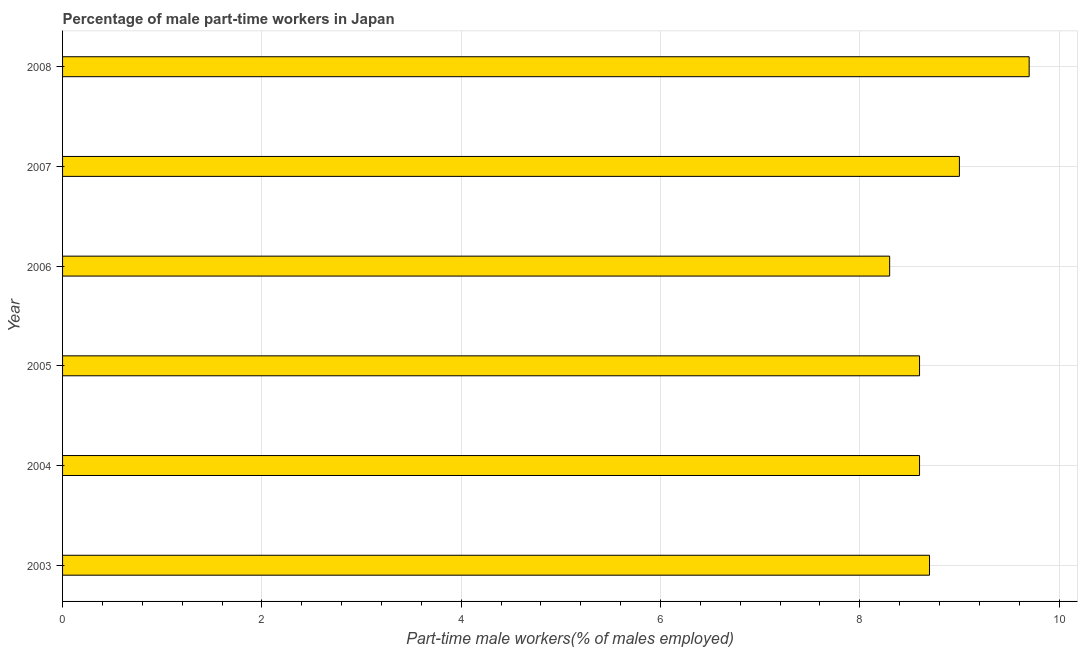Does the graph contain any zero values?
Keep it short and to the point. No. Does the graph contain grids?
Give a very brief answer. Yes. What is the title of the graph?
Ensure brevity in your answer.  Percentage of male part-time workers in Japan. What is the label or title of the X-axis?
Keep it short and to the point. Part-time male workers(% of males employed). What is the label or title of the Y-axis?
Ensure brevity in your answer.  Year. What is the percentage of part-time male workers in 2005?
Provide a short and direct response. 8.6. Across all years, what is the maximum percentage of part-time male workers?
Give a very brief answer. 9.7. Across all years, what is the minimum percentage of part-time male workers?
Your answer should be very brief. 8.3. In which year was the percentage of part-time male workers minimum?
Offer a very short reply. 2006. What is the sum of the percentage of part-time male workers?
Offer a very short reply. 52.9. What is the average percentage of part-time male workers per year?
Your response must be concise. 8.82. What is the median percentage of part-time male workers?
Your answer should be very brief. 8.65. What is the ratio of the percentage of part-time male workers in 2004 to that in 2007?
Make the answer very short. 0.96. Is the difference between the percentage of part-time male workers in 2003 and 2007 greater than the difference between any two years?
Your answer should be very brief. No. What is the difference between the highest and the second highest percentage of part-time male workers?
Give a very brief answer. 0.7. Are the values on the major ticks of X-axis written in scientific E-notation?
Your response must be concise. No. What is the Part-time male workers(% of males employed) of 2003?
Keep it short and to the point. 8.7. What is the Part-time male workers(% of males employed) in 2004?
Your response must be concise. 8.6. What is the Part-time male workers(% of males employed) in 2005?
Provide a short and direct response. 8.6. What is the Part-time male workers(% of males employed) in 2006?
Offer a very short reply. 8.3. What is the Part-time male workers(% of males employed) of 2008?
Your answer should be compact. 9.7. What is the difference between the Part-time male workers(% of males employed) in 2003 and 2005?
Offer a very short reply. 0.1. What is the difference between the Part-time male workers(% of males employed) in 2004 and 2005?
Offer a terse response. 0. What is the difference between the Part-time male workers(% of males employed) in 2004 and 2007?
Make the answer very short. -0.4. What is the difference between the Part-time male workers(% of males employed) in 2004 and 2008?
Your answer should be very brief. -1.1. What is the difference between the Part-time male workers(% of males employed) in 2005 and 2008?
Keep it short and to the point. -1.1. What is the difference between the Part-time male workers(% of males employed) in 2006 and 2007?
Keep it short and to the point. -0.7. What is the difference between the Part-time male workers(% of males employed) in 2006 and 2008?
Offer a very short reply. -1.4. What is the ratio of the Part-time male workers(% of males employed) in 2003 to that in 2004?
Provide a succinct answer. 1.01. What is the ratio of the Part-time male workers(% of males employed) in 2003 to that in 2006?
Ensure brevity in your answer.  1.05. What is the ratio of the Part-time male workers(% of males employed) in 2003 to that in 2008?
Offer a very short reply. 0.9. What is the ratio of the Part-time male workers(% of males employed) in 2004 to that in 2005?
Offer a terse response. 1. What is the ratio of the Part-time male workers(% of males employed) in 2004 to that in 2006?
Provide a short and direct response. 1.04. What is the ratio of the Part-time male workers(% of males employed) in 2004 to that in 2007?
Provide a short and direct response. 0.96. What is the ratio of the Part-time male workers(% of males employed) in 2004 to that in 2008?
Give a very brief answer. 0.89. What is the ratio of the Part-time male workers(% of males employed) in 2005 to that in 2006?
Keep it short and to the point. 1.04. What is the ratio of the Part-time male workers(% of males employed) in 2005 to that in 2007?
Provide a succinct answer. 0.96. What is the ratio of the Part-time male workers(% of males employed) in 2005 to that in 2008?
Make the answer very short. 0.89. What is the ratio of the Part-time male workers(% of males employed) in 2006 to that in 2007?
Offer a very short reply. 0.92. What is the ratio of the Part-time male workers(% of males employed) in 2006 to that in 2008?
Keep it short and to the point. 0.86. What is the ratio of the Part-time male workers(% of males employed) in 2007 to that in 2008?
Provide a short and direct response. 0.93. 